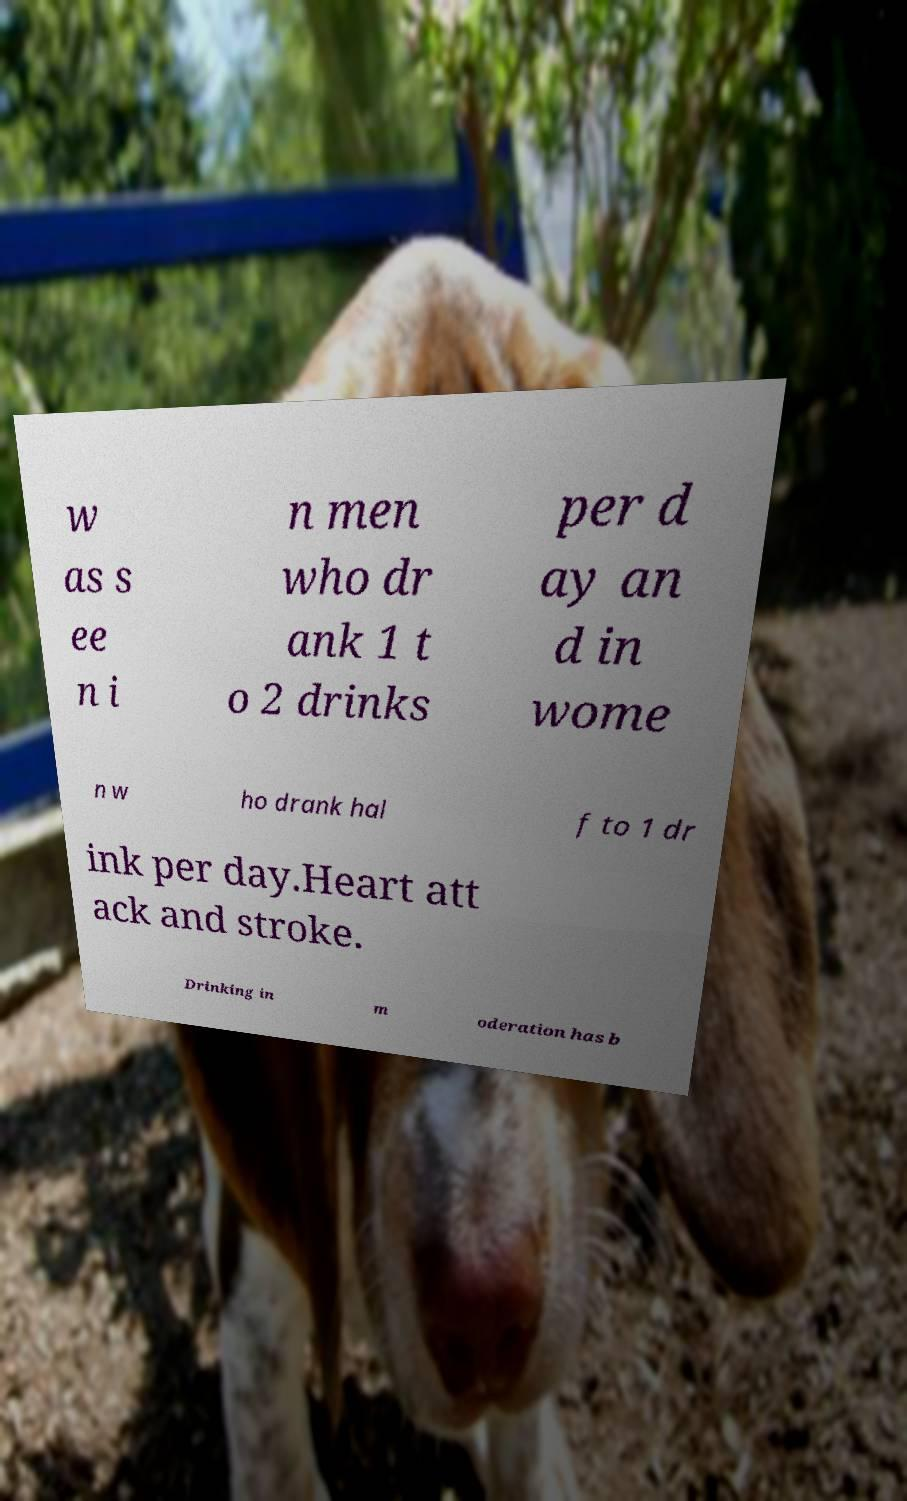Could you extract and type out the text from this image? w as s ee n i n men who dr ank 1 t o 2 drinks per d ay an d in wome n w ho drank hal f to 1 dr ink per day.Heart att ack and stroke. Drinking in m oderation has b 